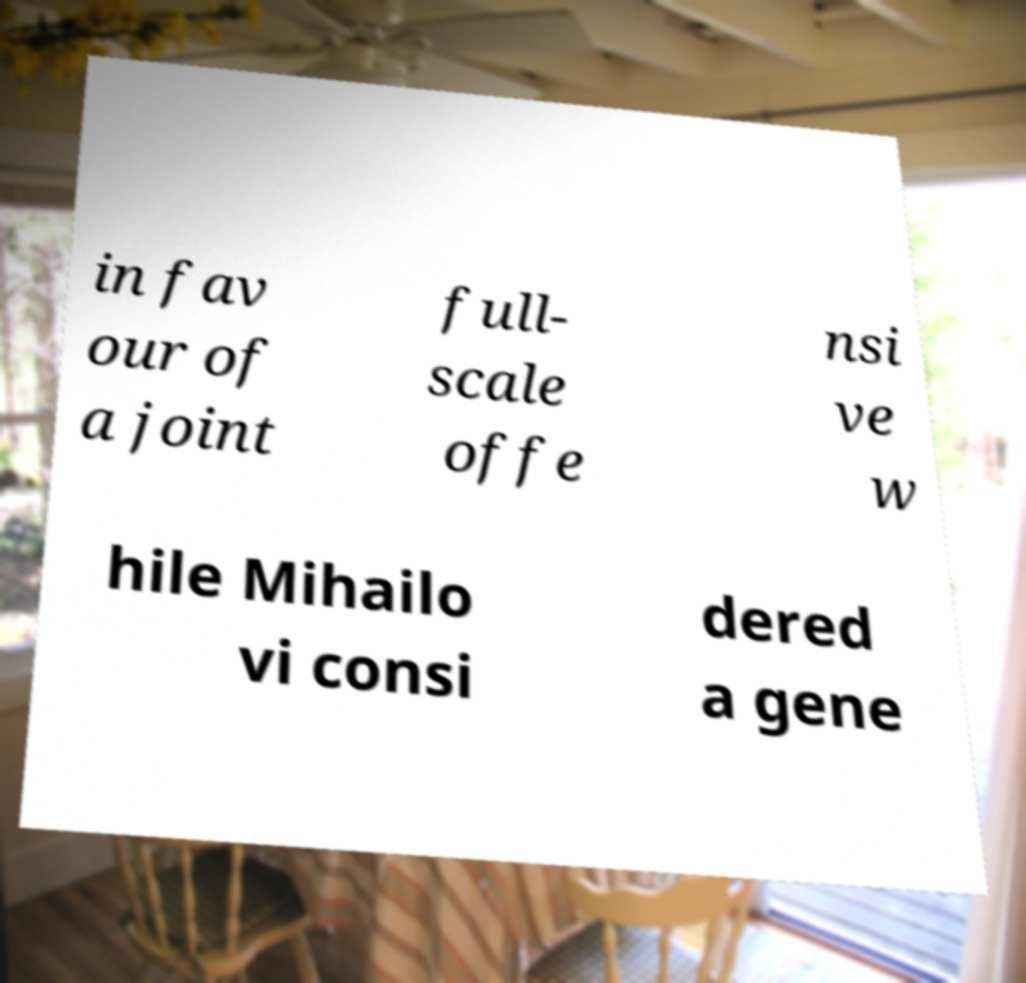Please identify and transcribe the text found in this image. in fav our of a joint full- scale offe nsi ve w hile Mihailo vi consi dered a gene 